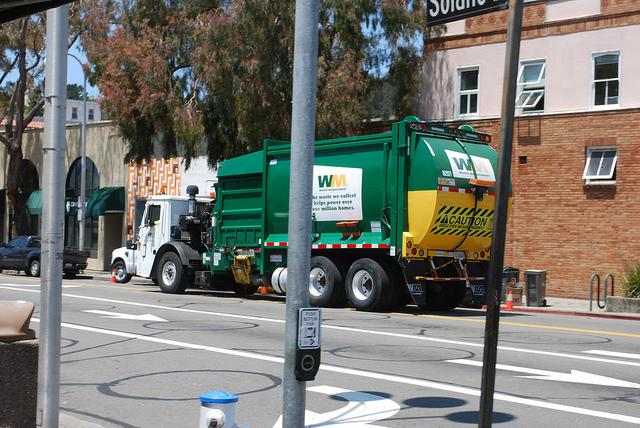What kind of product is likely hauled by the green truck? Please explain your reasoning. waste. Green trucks generally carry garbage. 